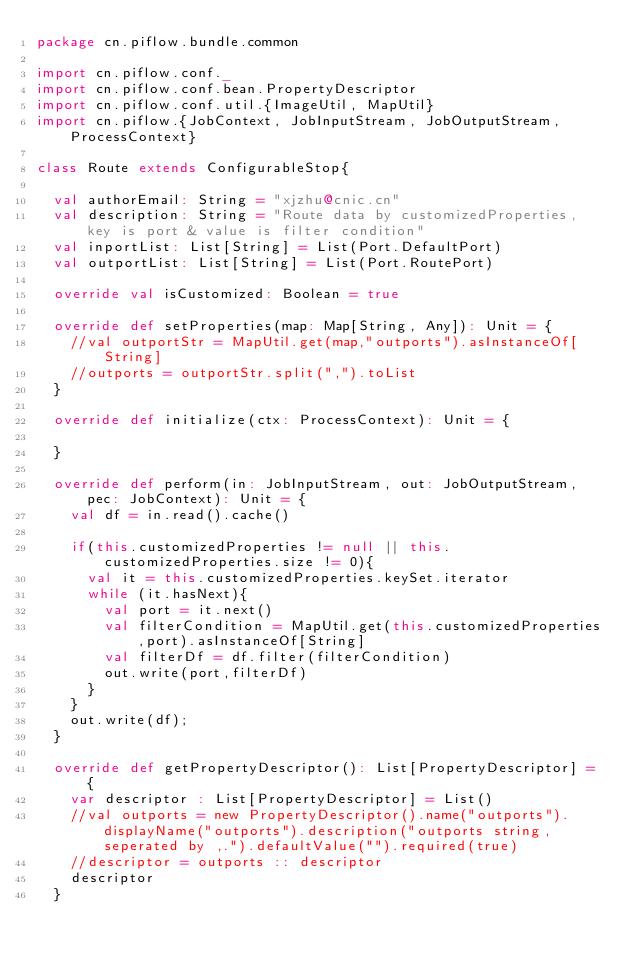<code> <loc_0><loc_0><loc_500><loc_500><_Scala_>package cn.piflow.bundle.common

import cn.piflow.conf._
import cn.piflow.conf.bean.PropertyDescriptor
import cn.piflow.conf.util.{ImageUtil, MapUtil}
import cn.piflow.{JobContext, JobInputStream, JobOutputStream, ProcessContext}

class Route extends ConfigurableStop{

  val authorEmail: String = "xjzhu@cnic.cn"
  val description: String = "Route data by customizedProperties, key is port & value is filter condition"
  val inportList: List[String] = List(Port.DefaultPort)
  val outportList: List[String] = List(Port.RoutePort)

  override val isCustomized: Boolean = true

  override def setProperties(map: Map[String, Any]): Unit = {
    //val outportStr = MapUtil.get(map,"outports").asInstanceOf[String]
    //outports = outportStr.split(",").toList
  }

  override def initialize(ctx: ProcessContext): Unit = {

  }

  override def perform(in: JobInputStream, out: JobOutputStream, pec: JobContext): Unit = {
    val df = in.read().cache()

    if(this.customizedProperties != null || this.customizedProperties.size != 0){
      val it = this.customizedProperties.keySet.iterator
      while (it.hasNext){
        val port = it.next()
        val filterCondition = MapUtil.get(this.customizedProperties,port).asInstanceOf[String]
        val filterDf = df.filter(filterCondition)
        out.write(port,filterDf)
      }
    }
    out.write(df);
  }

  override def getPropertyDescriptor(): List[PropertyDescriptor] = {
    var descriptor : List[PropertyDescriptor] = List()
    //val outports = new PropertyDescriptor().name("outports").displayName("outports").description("outports string, seperated by ,.").defaultValue("").required(true)
    //descriptor = outports :: descriptor
    descriptor
  }
</code> 